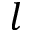<formula> <loc_0><loc_0><loc_500><loc_500>l</formula> 